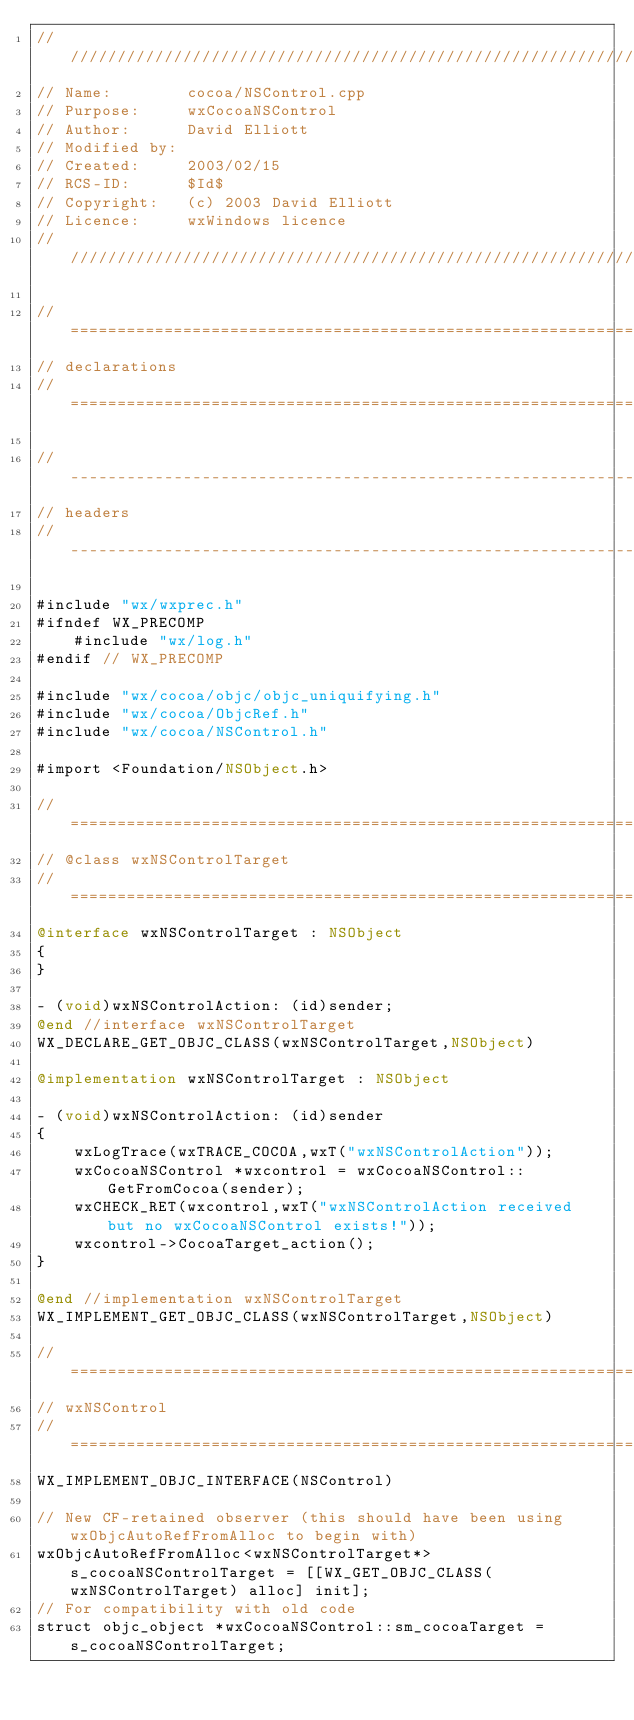<code> <loc_0><loc_0><loc_500><loc_500><_ObjectiveC_>/////////////////////////////////////////////////////////////////////////////
// Name:        cocoa/NSControl.cpp
// Purpose:     wxCocoaNSControl
// Author:      David Elliott
// Modified by:
// Created:     2003/02/15
// RCS-ID:      $Id$
// Copyright:   (c) 2003 David Elliott
// Licence:     wxWindows licence
/////////////////////////////////////////////////////////////////////////////

// ============================================================================
// declarations
// ============================================================================

// ----------------------------------------------------------------------------
// headers
// ----------------------------------------------------------------------------

#include "wx/wxprec.h"
#ifndef WX_PRECOMP
    #include "wx/log.h"
#endif // WX_PRECOMP

#include "wx/cocoa/objc/objc_uniquifying.h"
#include "wx/cocoa/ObjcRef.h"
#include "wx/cocoa/NSControl.h"

#import <Foundation/NSObject.h>

// ============================================================================
// @class wxNSControlTarget
// ============================================================================
@interface wxNSControlTarget : NSObject
{
}

- (void)wxNSControlAction: (id)sender;
@end //interface wxNSControlTarget
WX_DECLARE_GET_OBJC_CLASS(wxNSControlTarget,NSObject)

@implementation wxNSControlTarget : NSObject

- (void)wxNSControlAction: (id)sender
{
    wxLogTrace(wxTRACE_COCOA,wxT("wxNSControlAction"));
    wxCocoaNSControl *wxcontrol = wxCocoaNSControl::GetFromCocoa(sender);
    wxCHECK_RET(wxcontrol,wxT("wxNSControlAction received but no wxCocoaNSControl exists!"));
    wxcontrol->CocoaTarget_action();
}

@end //implementation wxNSControlTarget
WX_IMPLEMENT_GET_OBJC_CLASS(wxNSControlTarget,NSObject)

// ============================================================================
// wxNSControl
// ============================================================================
WX_IMPLEMENT_OBJC_INTERFACE(NSControl)

// New CF-retained observer (this should have been using wxObjcAutoRefFromAlloc to begin with)
wxObjcAutoRefFromAlloc<wxNSControlTarget*> s_cocoaNSControlTarget = [[WX_GET_OBJC_CLASS(wxNSControlTarget) alloc] init];
// For compatibility with old code
struct objc_object *wxCocoaNSControl::sm_cocoaTarget = s_cocoaNSControlTarget;

</code> 